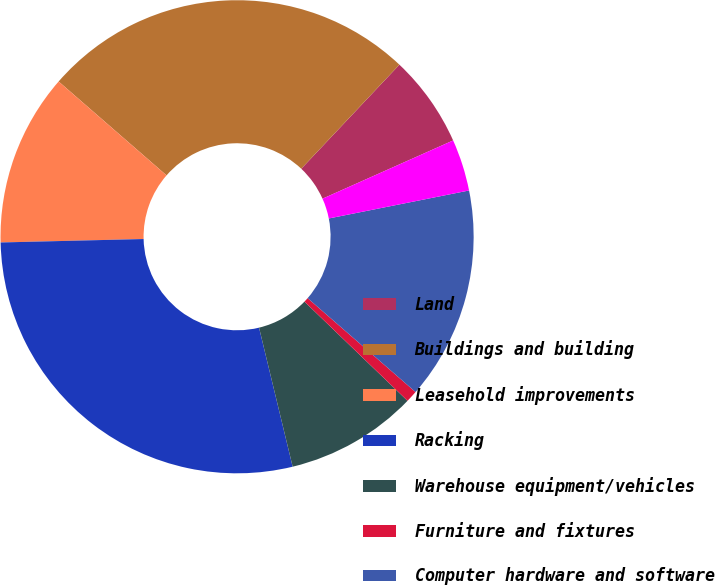Convert chart. <chart><loc_0><loc_0><loc_500><loc_500><pie_chart><fcel>Land<fcel>Buildings and building<fcel>Leasehold improvements<fcel>Racking<fcel>Warehouse equipment/vehicles<fcel>Furniture and fixtures<fcel>Computer hardware and software<fcel>Construction in progress<nl><fcel>6.29%<fcel>25.64%<fcel>11.78%<fcel>28.39%<fcel>9.03%<fcel>0.8%<fcel>14.53%<fcel>3.54%<nl></chart> 